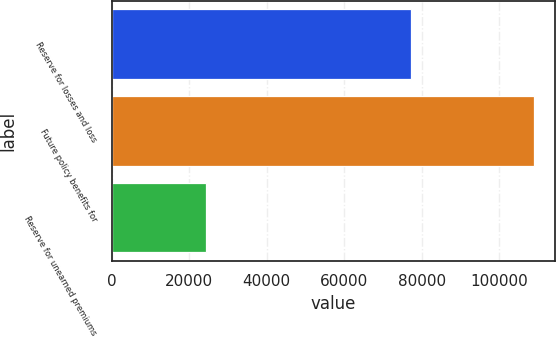Convert chart to OTSL. <chart><loc_0><loc_0><loc_500><loc_500><bar_chart><fcel>Reserve for losses and loss<fcel>Future policy benefits for<fcel>Reserve for unearned premiums<nl><fcel>77169<fcel>108807<fcel>24243<nl></chart> 